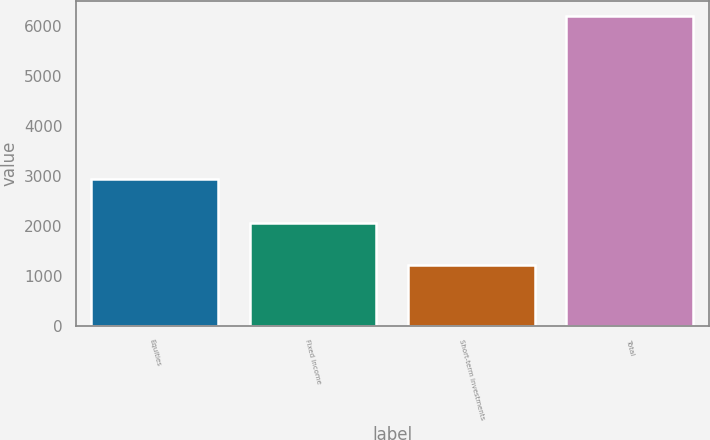<chart> <loc_0><loc_0><loc_500><loc_500><bar_chart><fcel>Equities<fcel>Fixed income<fcel>Short-term investments<fcel>Total<nl><fcel>2942<fcel>2055<fcel>1206<fcel>6203<nl></chart> 